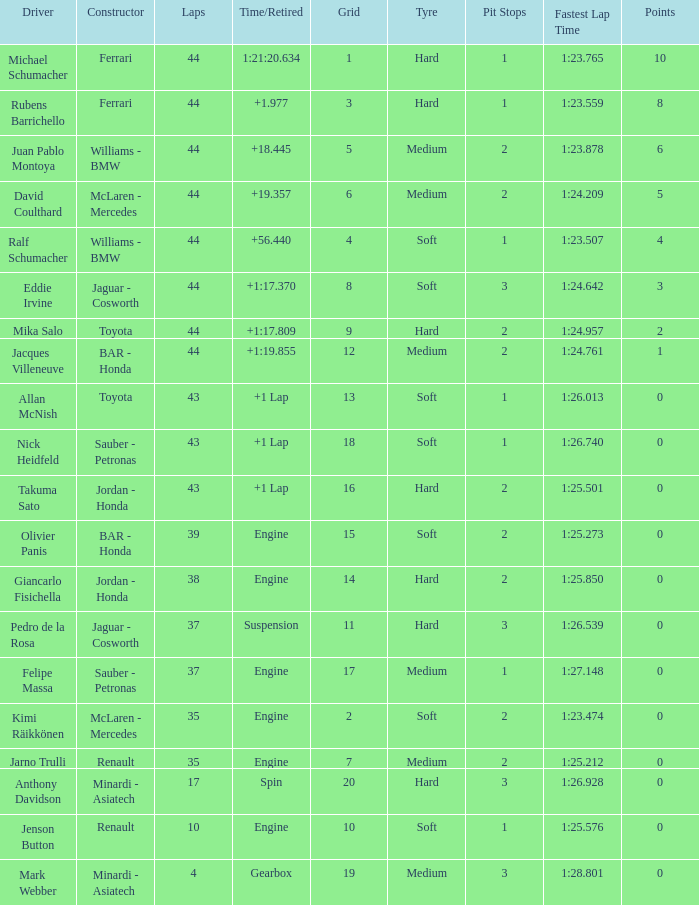What was the retired time on someone who had 43 laps on a grip of 18? +1 Lap. 